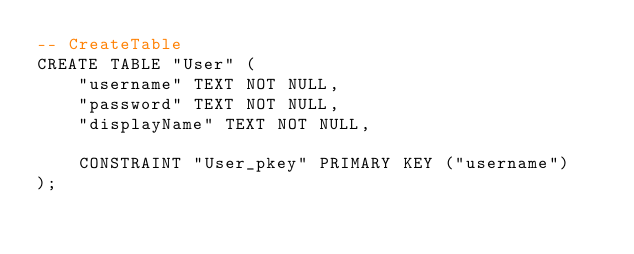Convert code to text. <code><loc_0><loc_0><loc_500><loc_500><_SQL_>-- CreateTable
CREATE TABLE "User" (
    "username" TEXT NOT NULL,
    "password" TEXT NOT NULL,
    "displayName" TEXT NOT NULL,

    CONSTRAINT "User_pkey" PRIMARY KEY ("username")
);
</code> 